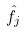<formula> <loc_0><loc_0><loc_500><loc_500>\hat { f _ { j } }</formula> 